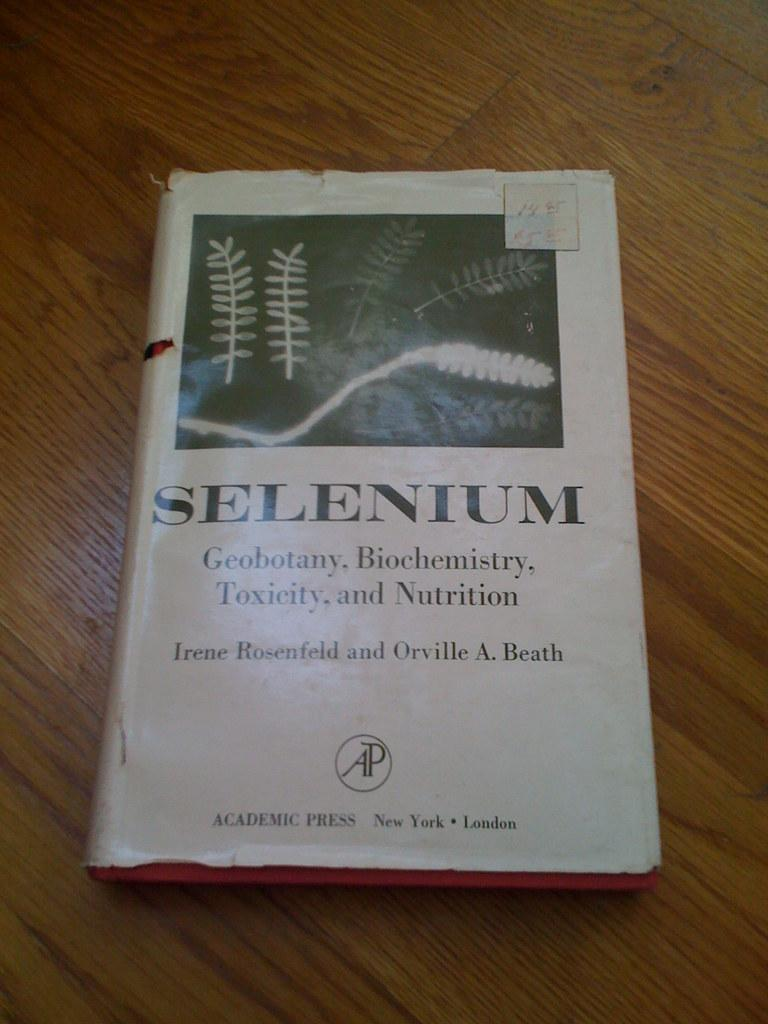<image>
Describe the image concisely. A book is on a table and it has the word SELENIUM on the cover. 